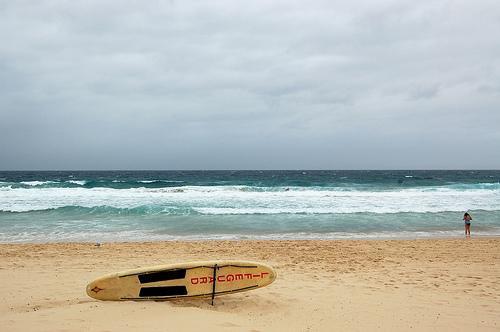How many people are on the beach?
Give a very brief answer. 1. How many rectangular black pads are on the surfboard?
Give a very brief answer. 2. How many giraffe are walking in the grass?
Give a very brief answer. 0. 